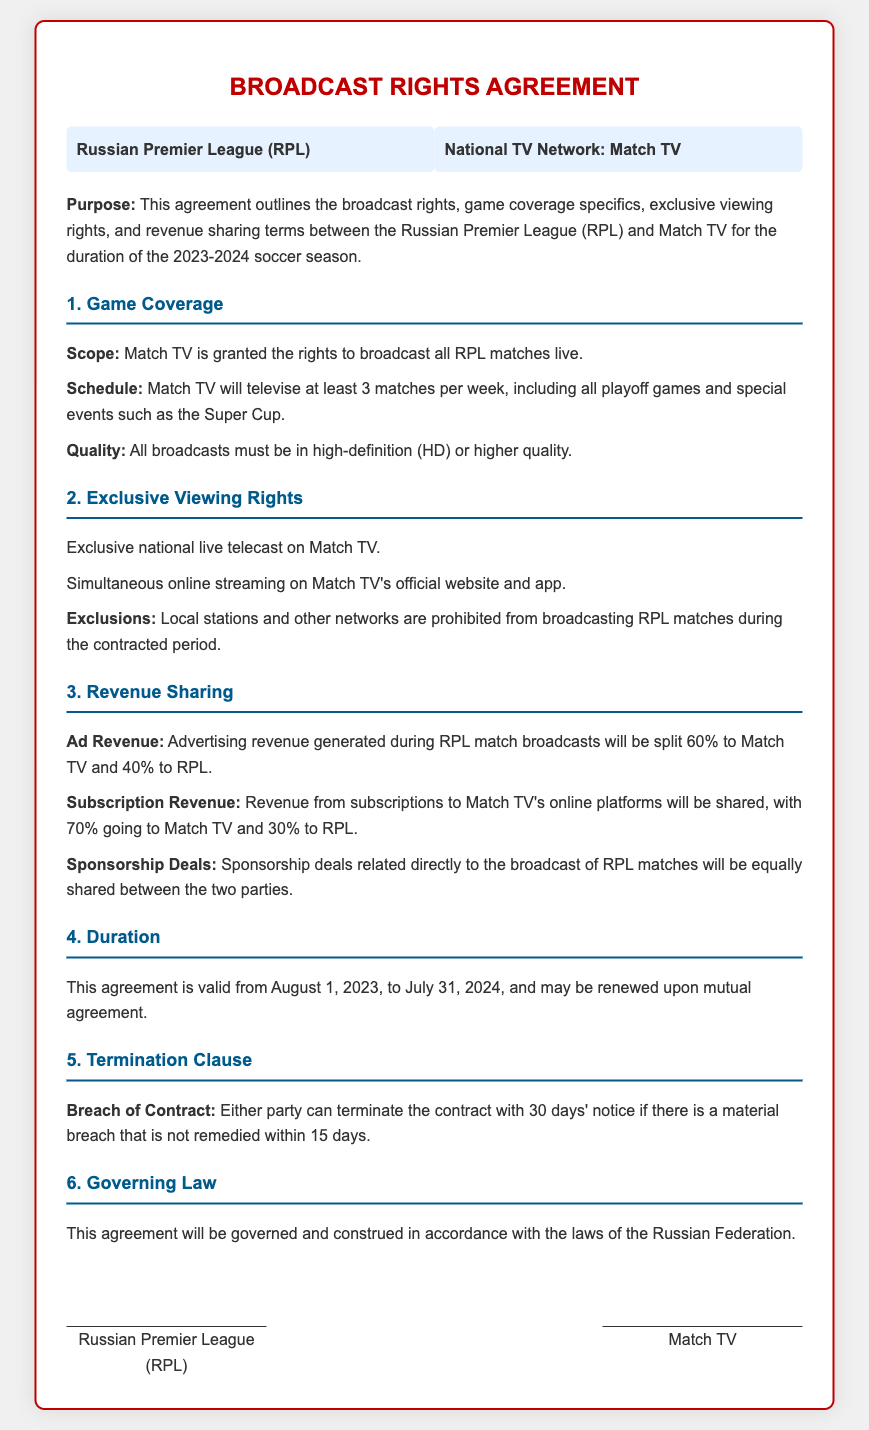What is the duration of the agreement? The duration of the agreement is specified in the document, stating it is valid from August 1, 2023, to July 31, 2024.
Answer: August 1, 2023, to July 31, 2024 Who are the parties involved in this agreement? The parties involved are listed at the beginning of the document: the Russian Premier League (RPL) and Match TV.
Answer: Russian Premier League (RPL) and Match TV What percentage of ad revenue goes to Match TV? The percentage of ad revenue allocated to Match TV is explicitly mentioned under the Revenue Sharing section.
Answer: 60% What is the quality requirement for broadcasting matches? The document outlines a quality requirement for broadcasts in the Game Coverage section, which pertains to the format used.
Answer: High-definition (HD) What happens if there is a breach of contract? The contract specifies the procedure following a breach of contract, indicating the steps that can be taken by either party.
Answer: 30 days' notice Are local stations allowed to broadcast RPL matches? The document contains information on the exclusivity of viewing rights, specifically mentioning restrictions on other networks during the contract period.
Answer: No What is the revenue share for subscription revenue between Match TV and RPL? The percentages regarding subscription revenue split are clearly defined in the Revenue Sharing section of the document.
Answer: 70% to Match TV and 30% to RPL What must Match TV do regarding playoff games? The document describes obligations related to playoff games under the Game Coverage section, specifying how many matches must be televised.
Answer: Televise all playoff games What is the governing law for this agreement? The governing law is stated in the document and refers to the legal jurisdiction that oversees the contract.
Answer: Laws of the Russian Federation 